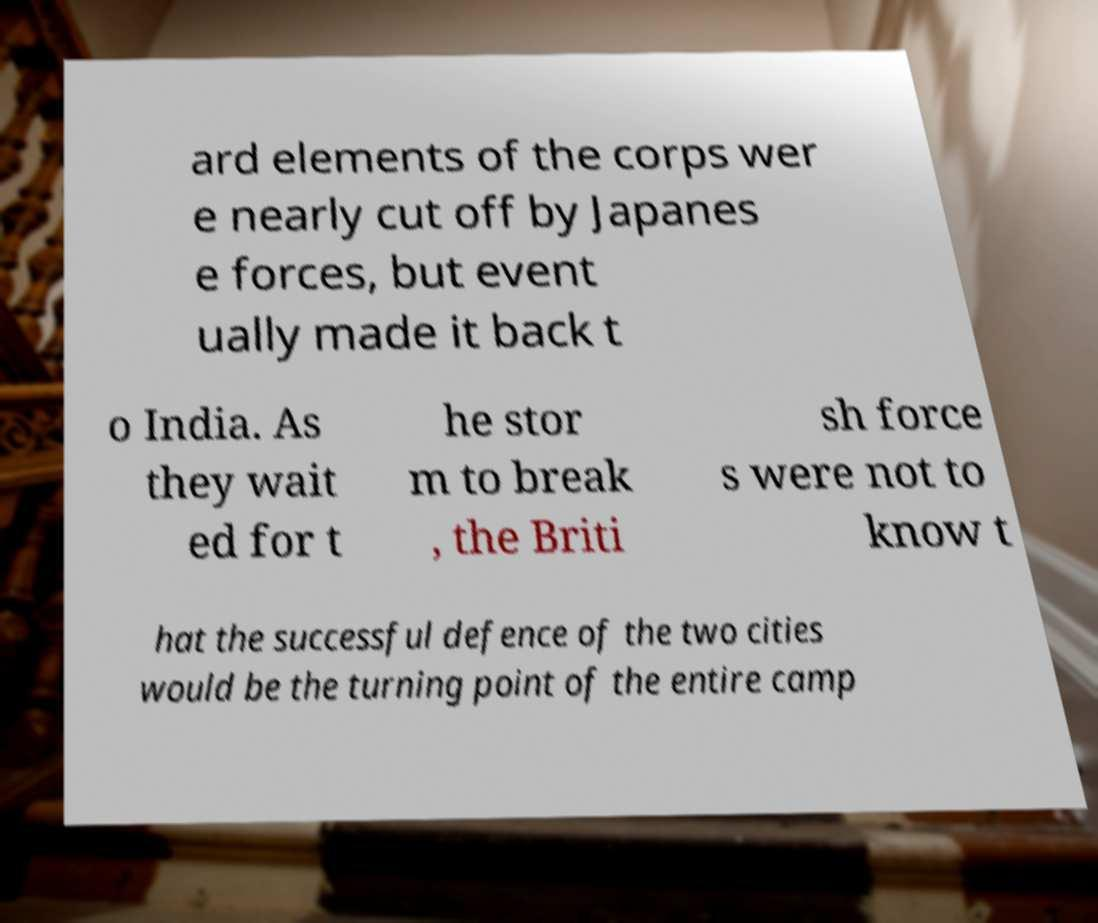Can you read and provide the text displayed in the image?This photo seems to have some interesting text. Can you extract and type it out for me? ard elements of the corps wer e nearly cut off by Japanes e forces, but event ually made it back t o India. As they wait ed for t he stor m to break , the Briti sh force s were not to know t hat the successful defence of the two cities would be the turning point of the entire camp 